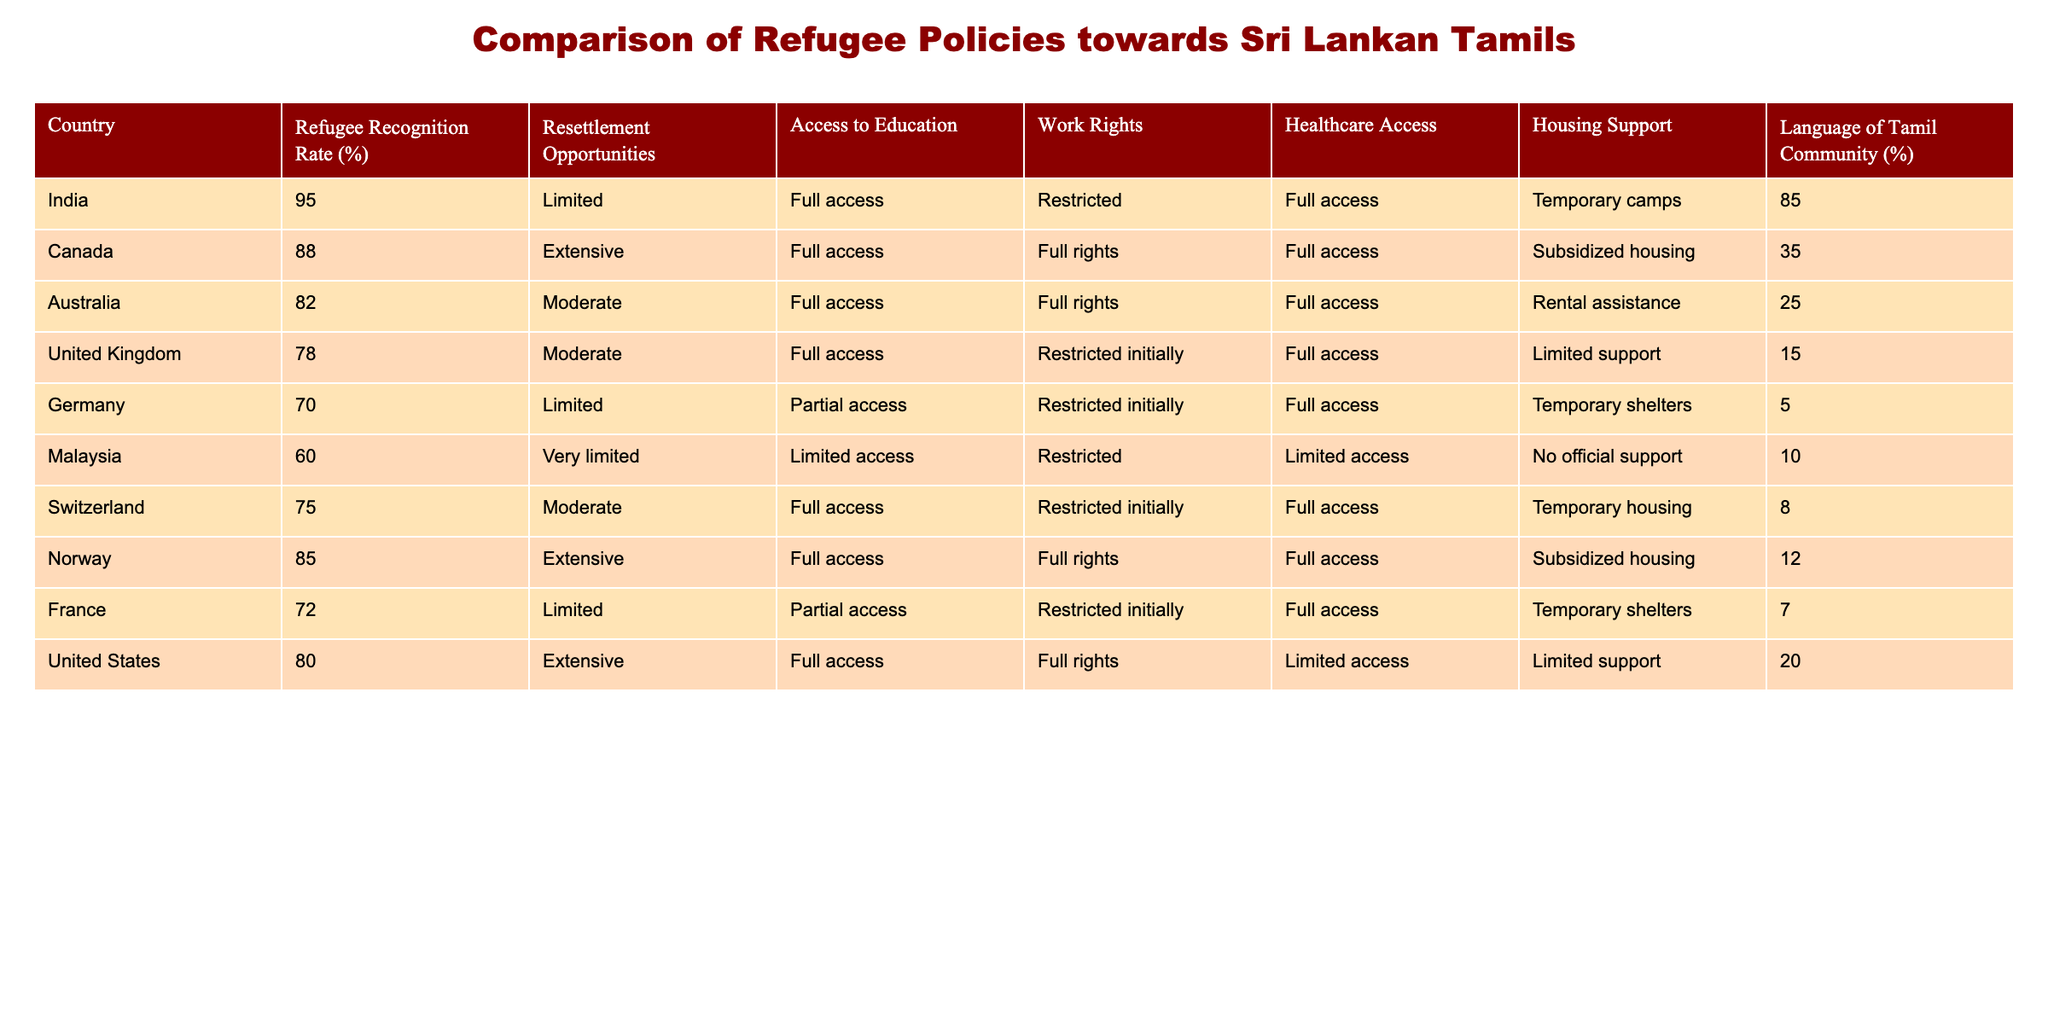What is the refugee recognition rate for India? The table shows that India's refugee recognition rate is 95%. This is found in the "Refugee Recognition Rate (%)" column under the row for India.
Answer: 95% Which country has the highest access to healthcare for Sri Lankan Tamils? According to the table, India has full access to healthcare, which is the highest among the countries listed. This can be located in the "Healthcare Access" column for India.
Answer: India How many countries provide full work rights for Sri Lankan Tamils? There are four countries that provide full work rights: India, Australia, Norway, and the United States. By checking the "Work Rights" column, we can identify these countries with "Full rights".
Answer: Four What is the average refugee recognition rate for the countries in the table? To calculate the average recognition rate, we sum the values (95 + 88 + 82 + 78 + 70 + 60 + 75 + 85 + 72 + 80) = 800, and then divide by the number of countries (10), resulting in an average of 80%.
Answer: 80% Does any country offer temporary housing support for Sri Lankan Tamils? Yes, both India and Germany provide temporary housing support according to the "Housing Support" column, indicating 'Temporary camps' for India and 'Temporary shelters' for Germany.
Answer: Yes Which country has the lowest access to education for Sri Lankan Tamils? The table lists Germany and Malaysia with limited educational access, marked as "Partial access" and "Limited access" respectively. Since "Limited access" is lower than "Partial access", Malaysia has the lowest access.
Answer: Malaysia Is it true that Canada offers extensive resettlement opportunities for Sri Lankan Tamils? Yes, the table confirms that Canada has "Extensive" resettlement opportunities, as specified in the "Resettlement Opportunities" column.
Answer: Yes How many countries have a language community percentage of 20 or less? The countries with a language community percentage of 20 or less are Germany (5%), Malaysia (10%), Switzerland (8%), and France (7%). This totals four countries based on the "Language of Tamil Community (%)" column.
Answer: Four 